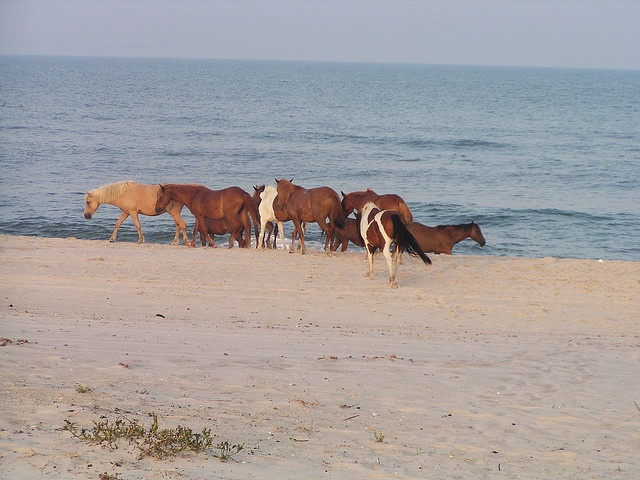Describe the objects in this image and their specific colors. I can see horse in darkgray, maroon, and brown tones, horse in darkgray, black, maroon, and tan tones, horse in darkgray, tan, and salmon tones, horse in darkgray, maroon, and brown tones, and horse in darkgray, maroon, brown, black, and gray tones in this image. 